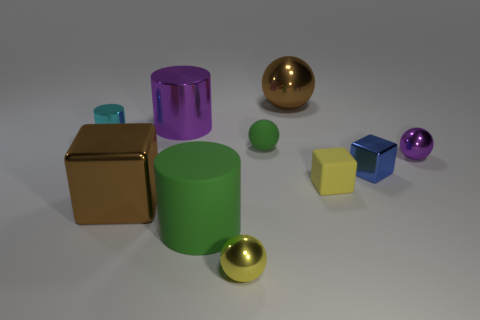There is a small cyan shiny thing; is it the same shape as the green thing in front of the tiny yellow cube?
Your response must be concise. Yes. How many other objects are there of the same size as the matte cylinder?
Provide a succinct answer. 3. How many purple things are either cubes or spheres?
Keep it short and to the point. 1. How many large metal things are both behind the purple sphere and in front of the blue shiny cube?
Provide a succinct answer. 0. There is a ball right of the tiny yellow thing that is to the right of the big brown object on the right side of the brown block; what is it made of?
Offer a very short reply. Metal. What number of tiny blue cubes are made of the same material as the green sphere?
Your response must be concise. 0. What is the shape of the object that is the same color as the rubber cylinder?
Make the answer very short. Sphere. There is a green matte object that is the same size as the brown shiny block; what is its shape?
Keep it short and to the point. Cylinder. There is another thing that is the same color as the big rubber object; what is its material?
Provide a succinct answer. Rubber. There is a small purple shiny ball; are there any large brown shiny spheres on the right side of it?
Make the answer very short. No. 